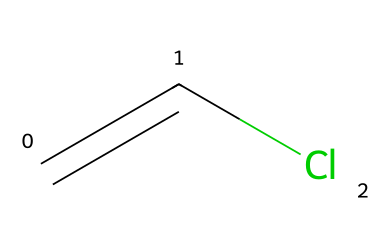What is the chemical name represented by this SMILES? The SMILES C=CCl corresponds to the chemical structure known as vinyl chloride, which has a double bond between the two carbon atoms and is bonded to a chlorine atom.
Answer: vinyl chloride How many carbon atoms are present in the structure? In the given SMILES C=CCl, there are two carbon atoms, indicated by the "C" characters.
Answer: 2 What type of bond connects the carbon atoms? The SMILES shows "C=C", which indicates a double bond between the two carbon atoms.
Answer: double bond How many total atoms are present in this chemical? Counting the atoms in the SMILES, there are 2 carbon atoms and 1 chlorine atom, making a total of 3 atoms.
Answer: 3 What is the functional group present in this monomer? The presence of the chlorine atom (Cl) attached to the carbon chain indicates that the functional group is a haloalkane.
Answer: haloalkane What is the significance of the double bond in vinyl chloride? The double bond in vinyl chloride makes it an alkene, increasing its reactivity and allowing it to polymerize to form PVC, which is essential for its applications in electrical cable coatings.
Answer: polymerization Is this monomer polar or non-polar? The presence of the chlorine atom introduces polarity due to the electronegativity difference between C and Cl, making it a polar molecule.
Answer: polar 